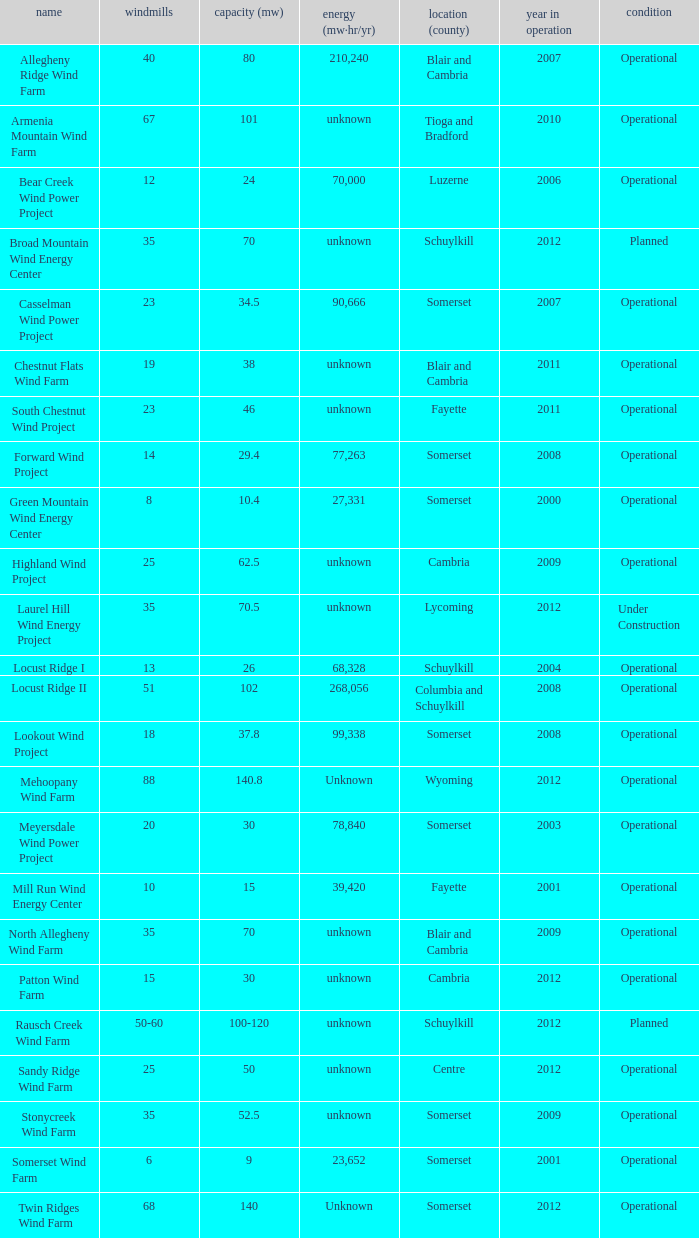What farm has a capacity of 70 and is operational? North Allegheny Wind Farm. 